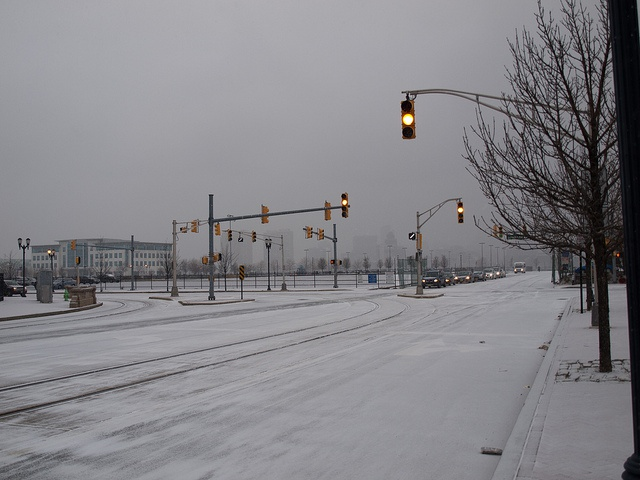Describe the objects in this image and their specific colors. I can see traffic light in darkgray, gray, black, and maroon tones, traffic light in darkgray, black, maroon, white, and yellow tones, truck in darkgray, black, and gray tones, car in darkgray, black, gray, and purple tones, and car in darkgray, gray, and black tones in this image. 